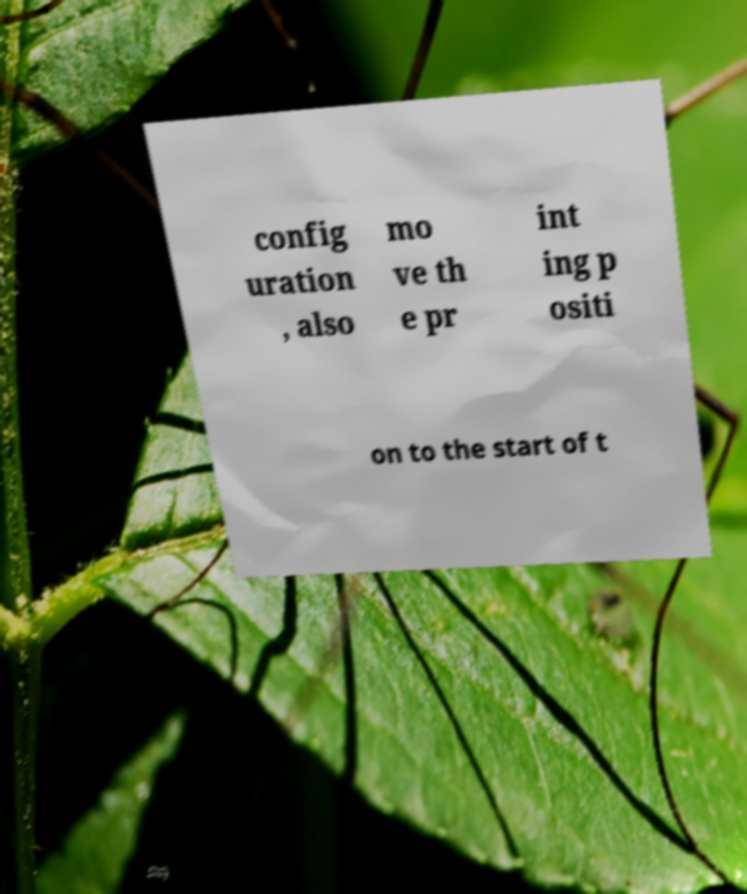There's text embedded in this image that I need extracted. Can you transcribe it verbatim? config uration , also mo ve th e pr int ing p ositi on to the start of t 